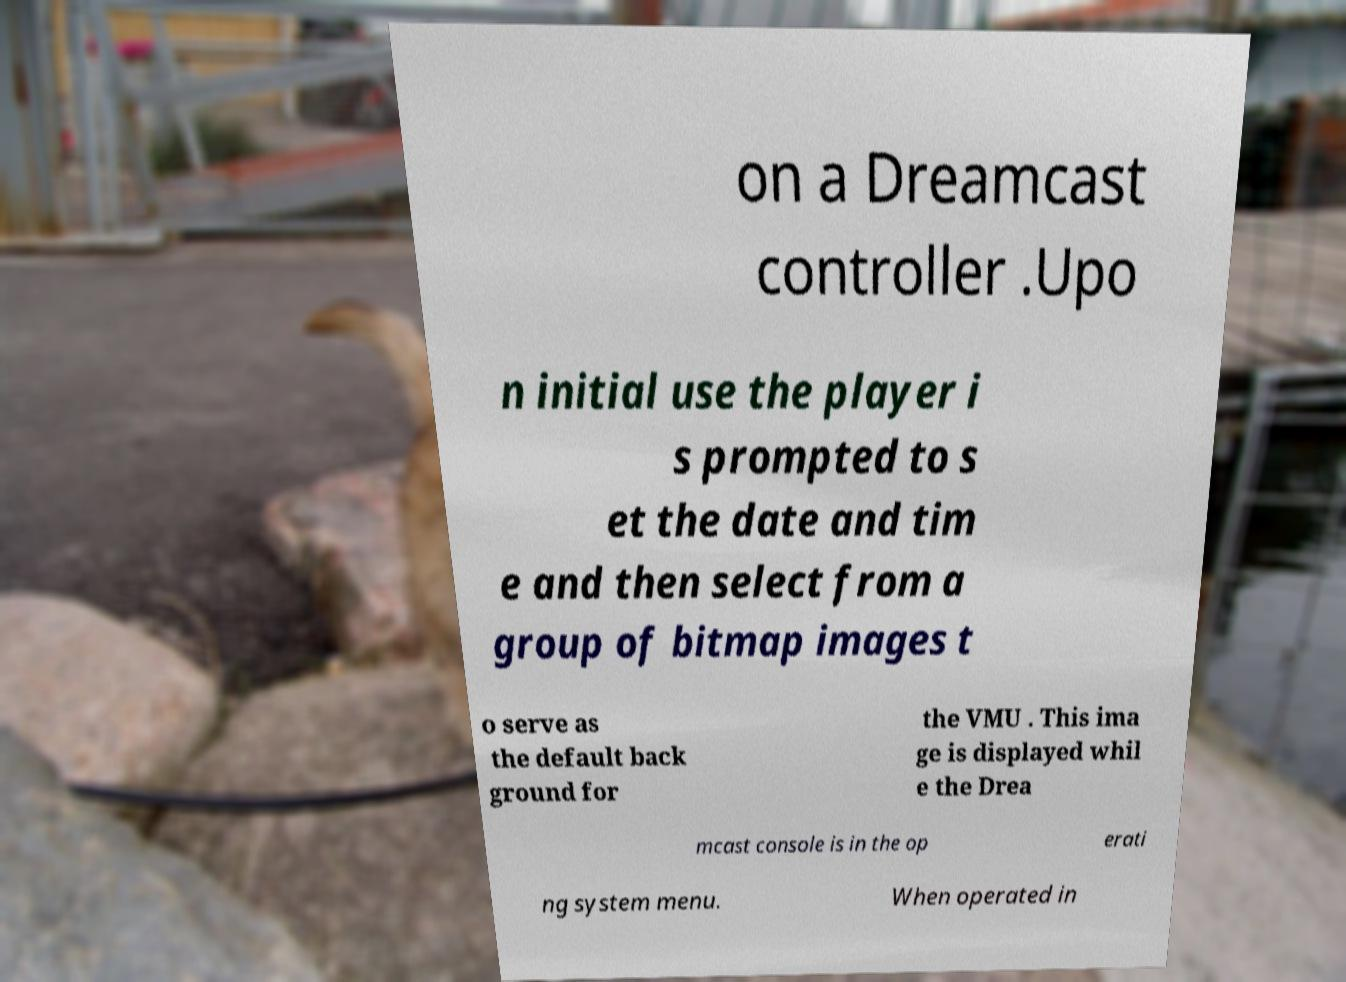Please read and relay the text visible in this image. What does it say? on a Dreamcast controller .Upo n initial use the player i s prompted to s et the date and tim e and then select from a group of bitmap images t o serve as the default back ground for the VMU . This ima ge is displayed whil e the Drea mcast console is in the op erati ng system menu. When operated in 